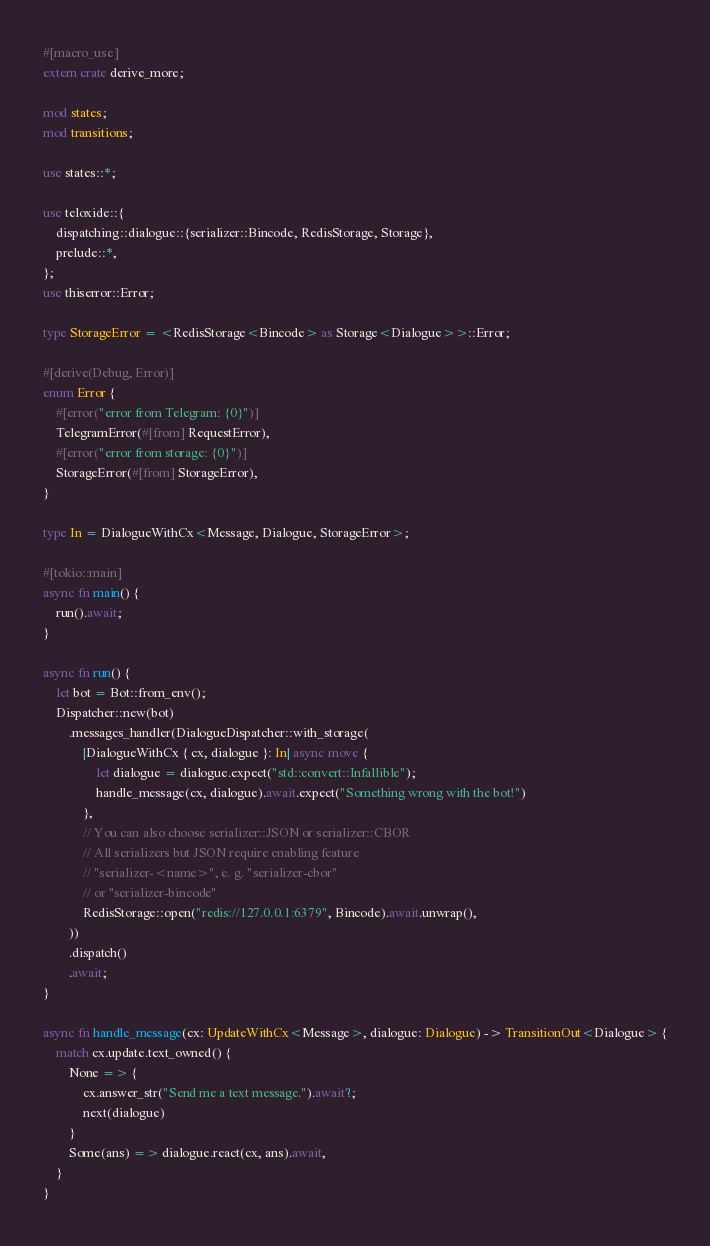<code> <loc_0><loc_0><loc_500><loc_500><_Rust_>#[macro_use]
extern crate derive_more;

mod states;
mod transitions;

use states::*;

use teloxide::{
    dispatching::dialogue::{serializer::Bincode, RedisStorage, Storage},
    prelude::*,
};
use thiserror::Error;

type StorageError = <RedisStorage<Bincode> as Storage<Dialogue>>::Error;

#[derive(Debug, Error)]
enum Error {
    #[error("error from Telegram: {0}")]
    TelegramError(#[from] RequestError),
    #[error("error from storage: {0}")]
    StorageError(#[from] StorageError),
}

type In = DialogueWithCx<Message, Dialogue, StorageError>;

#[tokio::main]
async fn main() {
    run().await;
}

async fn run() {
    let bot = Bot::from_env();
    Dispatcher::new(bot)
        .messages_handler(DialogueDispatcher::with_storage(
            |DialogueWithCx { cx, dialogue }: In| async move {
                let dialogue = dialogue.expect("std::convert::Infallible");
                handle_message(cx, dialogue).await.expect("Something wrong with the bot!")
            },
            // You can also choose serializer::JSON or serializer::CBOR
            // All serializers but JSON require enabling feature
            // "serializer-<name>", e. g. "serializer-cbor"
            // or "serializer-bincode"
            RedisStorage::open("redis://127.0.0.1:6379", Bincode).await.unwrap(),
        ))
        .dispatch()
        .await;
}

async fn handle_message(cx: UpdateWithCx<Message>, dialogue: Dialogue) -> TransitionOut<Dialogue> {
    match cx.update.text_owned() {
        None => {
            cx.answer_str("Send me a text message.").await?;
            next(dialogue)
        }
        Some(ans) => dialogue.react(cx, ans).await,
    }
}
</code> 